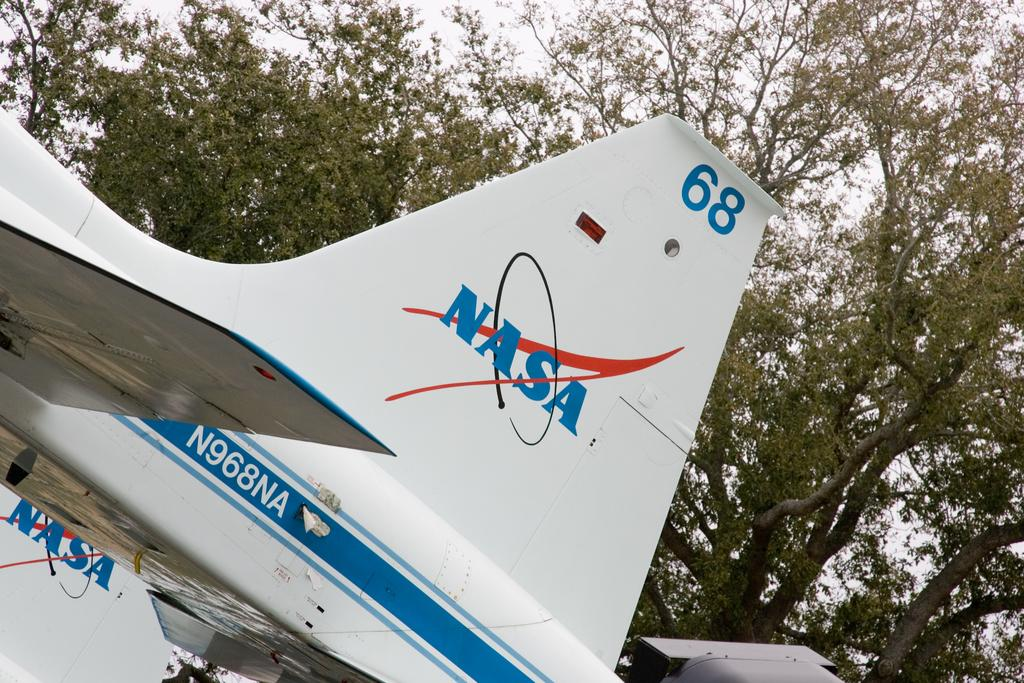<image>
Summarize the visual content of the image. The tail of a plane that says NASA, 68 and N968NA. 